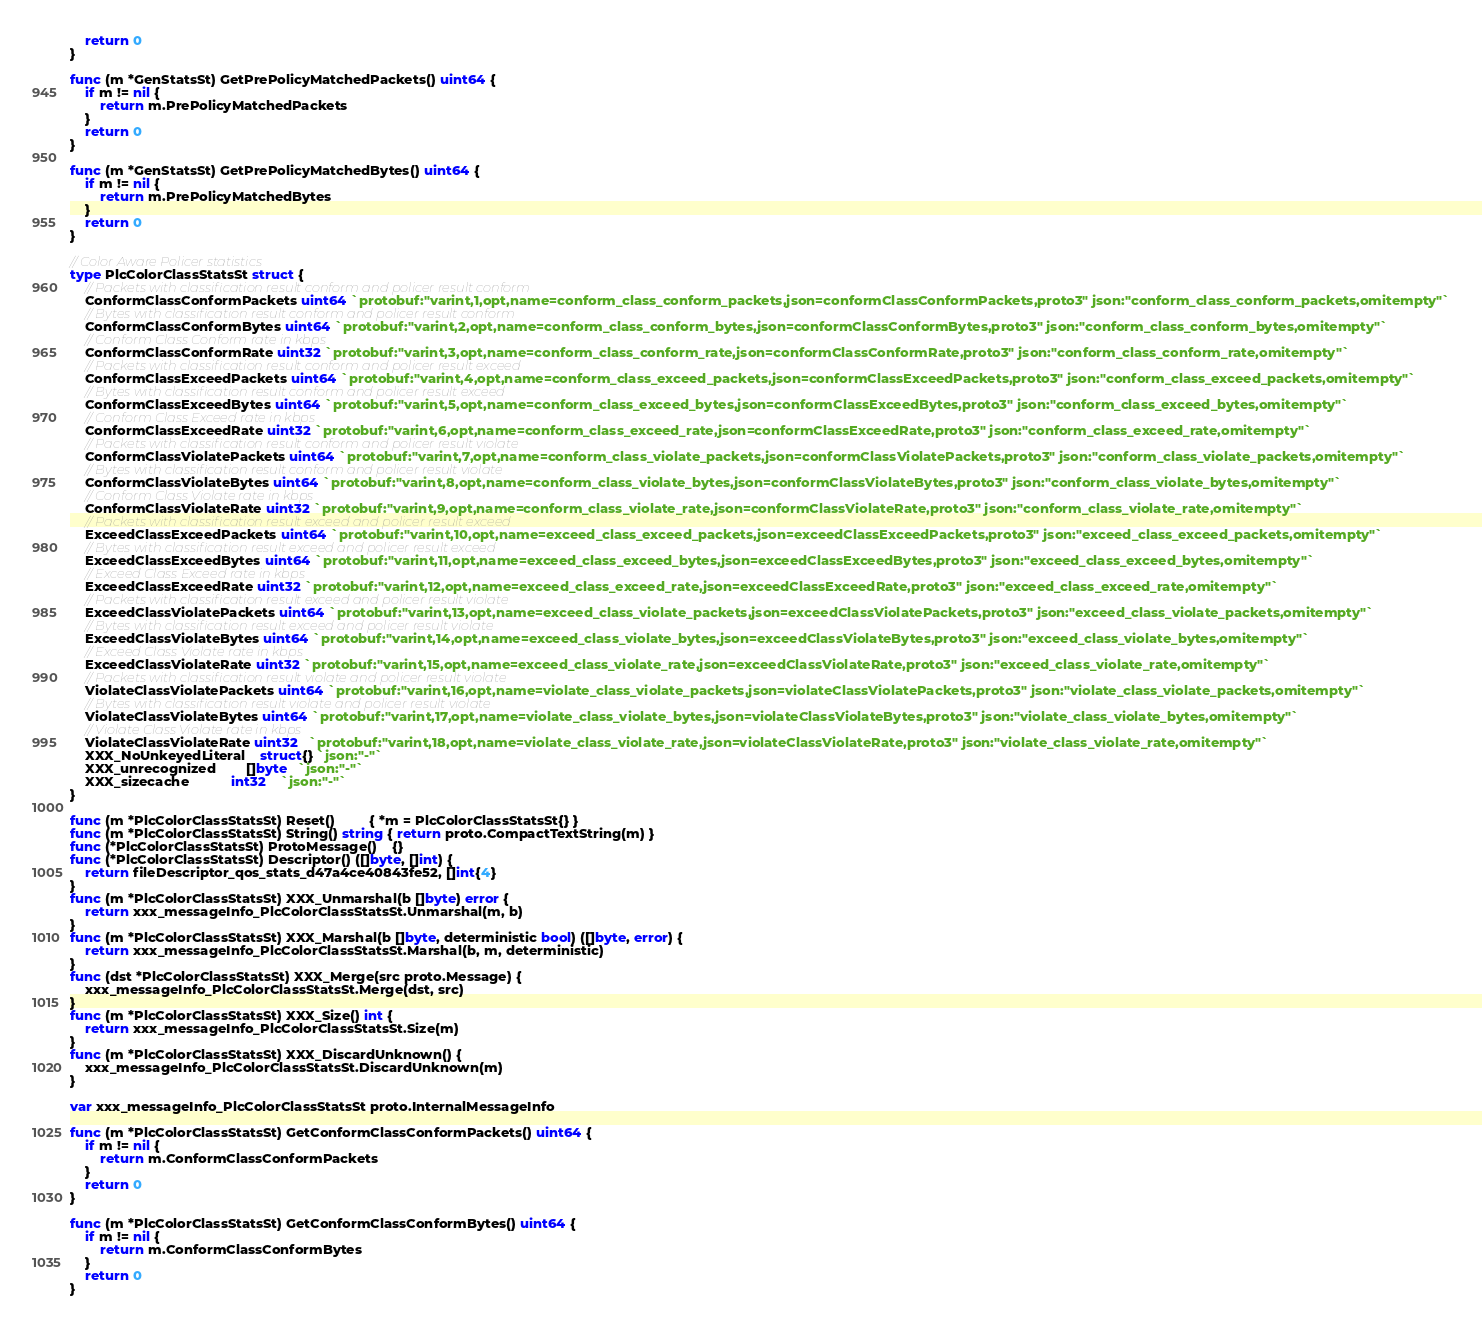<code> <loc_0><loc_0><loc_500><loc_500><_Go_>	return 0
}

func (m *GenStatsSt) GetPrePolicyMatchedPackets() uint64 {
	if m != nil {
		return m.PrePolicyMatchedPackets
	}
	return 0
}

func (m *GenStatsSt) GetPrePolicyMatchedBytes() uint64 {
	if m != nil {
		return m.PrePolicyMatchedBytes
	}
	return 0
}

// Color Aware Policer statistics
type PlcColorClassStatsSt struct {
	// Packets with classification result conform and policer result conform
	ConformClassConformPackets uint64 `protobuf:"varint,1,opt,name=conform_class_conform_packets,json=conformClassConformPackets,proto3" json:"conform_class_conform_packets,omitempty"`
	// Bytes with classification result conform and policer result conform
	ConformClassConformBytes uint64 `protobuf:"varint,2,opt,name=conform_class_conform_bytes,json=conformClassConformBytes,proto3" json:"conform_class_conform_bytes,omitempty"`
	// Conform Class Conform rate in kbps
	ConformClassConformRate uint32 `protobuf:"varint,3,opt,name=conform_class_conform_rate,json=conformClassConformRate,proto3" json:"conform_class_conform_rate,omitempty"`
	// Packets with classification result conform and policer result exceed
	ConformClassExceedPackets uint64 `protobuf:"varint,4,opt,name=conform_class_exceed_packets,json=conformClassExceedPackets,proto3" json:"conform_class_exceed_packets,omitempty"`
	// Bytes with classification result conform and policer result exceed
	ConformClassExceedBytes uint64 `protobuf:"varint,5,opt,name=conform_class_exceed_bytes,json=conformClassExceedBytes,proto3" json:"conform_class_exceed_bytes,omitempty"`
	// Conform Class Exceed rate in kbps
	ConformClassExceedRate uint32 `protobuf:"varint,6,opt,name=conform_class_exceed_rate,json=conformClassExceedRate,proto3" json:"conform_class_exceed_rate,omitempty"`
	// Packets with classification result conform and policer result violate
	ConformClassViolatePackets uint64 `protobuf:"varint,7,opt,name=conform_class_violate_packets,json=conformClassViolatePackets,proto3" json:"conform_class_violate_packets,omitempty"`
	// Bytes with classification result conform and policer result violate
	ConformClassViolateBytes uint64 `protobuf:"varint,8,opt,name=conform_class_violate_bytes,json=conformClassViolateBytes,proto3" json:"conform_class_violate_bytes,omitempty"`
	// Conform Class Violate rate in kbps
	ConformClassViolateRate uint32 `protobuf:"varint,9,opt,name=conform_class_violate_rate,json=conformClassViolateRate,proto3" json:"conform_class_violate_rate,omitempty"`
	// Packets with classification result exceed and policer result exceed
	ExceedClassExceedPackets uint64 `protobuf:"varint,10,opt,name=exceed_class_exceed_packets,json=exceedClassExceedPackets,proto3" json:"exceed_class_exceed_packets,omitempty"`
	// Bytes with classification result exceed and policer result exceed
	ExceedClassExceedBytes uint64 `protobuf:"varint,11,opt,name=exceed_class_exceed_bytes,json=exceedClassExceedBytes,proto3" json:"exceed_class_exceed_bytes,omitempty"`
	// Exceed Class Exceed rate in kbps
	ExceedClassExceedRate uint32 `protobuf:"varint,12,opt,name=exceed_class_exceed_rate,json=exceedClassExceedRate,proto3" json:"exceed_class_exceed_rate,omitempty"`
	// Packets with classification result exceed and policer result violate
	ExceedClassViolatePackets uint64 `protobuf:"varint,13,opt,name=exceed_class_violate_packets,json=exceedClassViolatePackets,proto3" json:"exceed_class_violate_packets,omitempty"`
	// Bytes with classification result exceed and policer result violate
	ExceedClassViolateBytes uint64 `protobuf:"varint,14,opt,name=exceed_class_violate_bytes,json=exceedClassViolateBytes,proto3" json:"exceed_class_violate_bytes,omitempty"`
	// Exceed Class Violate rate in kbps
	ExceedClassViolateRate uint32 `protobuf:"varint,15,opt,name=exceed_class_violate_rate,json=exceedClassViolateRate,proto3" json:"exceed_class_violate_rate,omitempty"`
	// Packets with classification result violate and policer result violate
	ViolateClassViolatePackets uint64 `protobuf:"varint,16,opt,name=violate_class_violate_packets,json=violateClassViolatePackets,proto3" json:"violate_class_violate_packets,omitempty"`
	// Bytes with classification result violate and policer result violate
	ViolateClassViolateBytes uint64 `protobuf:"varint,17,opt,name=violate_class_violate_bytes,json=violateClassViolateBytes,proto3" json:"violate_class_violate_bytes,omitempty"`
	// Violate Class Violate rate in kbps
	ViolateClassViolateRate uint32   `protobuf:"varint,18,opt,name=violate_class_violate_rate,json=violateClassViolateRate,proto3" json:"violate_class_violate_rate,omitempty"`
	XXX_NoUnkeyedLiteral    struct{} `json:"-"`
	XXX_unrecognized        []byte   `json:"-"`
	XXX_sizecache           int32    `json:"-"`
}

func (m *PlcColorClassStatsSt) Reset()         { *m = PlcColorClassStatsSt{} }
func (m *PlcColorClassStatsSt) String() string { return proto.CompactTextString(m) }
func (*PlcColorClassStatsSt) ProtoMessage()    {}
func (*PlcColorClassStatsSt) Descriptor() ([]byte, []int) {
	return fileDescriptor_qos_stats_d47a4ce40843fe52, []int{4}
}
func (m *PlcColorClassStatsSt) XXX_Unmarshal(b []byte) error {
	return xxx_messageInfo_PlcColorClassStatsSt.Unmarshal(m, b)
}
func (m *PlcColorClassStatsSt) XXX_Marshal(b []byte, deterministic bool) ([]byte, error) {
	return xxx_messageInfo_PlcColorClassStatsSt.Marshal(b, m, deterministic)
}
func (dst *PlcColorClassStatsSt) XXX_Merge(src proto.Message) {
	xxx_messageInfo_PlcColorClassStatsSt.Merge(dst, src)
}
func (m *PlcColorClassStatsSt) XXX_Size() int {
	return xxx_messageInfo_PlcColorClassStatsSt.Size(m)
}
func (m *PlcColorClassStatsSt) XXX_DiscardUnknown() {
	xxx_messageInfo_PlcColorClassStatsSt.DiscardUnknown(m)
}

var xxx_messageInfo_PlcColorClassStatsSt proto.InternalMessageInfo

func (m *PlcColorClassStatsSt) GetConformClassConformPackets() uint64 {
	if m != nil {
		return m.ConformClassConformPackets
	}
	return 0
}

func (m *PlcColorClassStatsSt) GetConformClassConformBytes() uint64 {
	if m != nil {
		return m.ConformClassConformBytes
	}
	return 0
}
</code> 